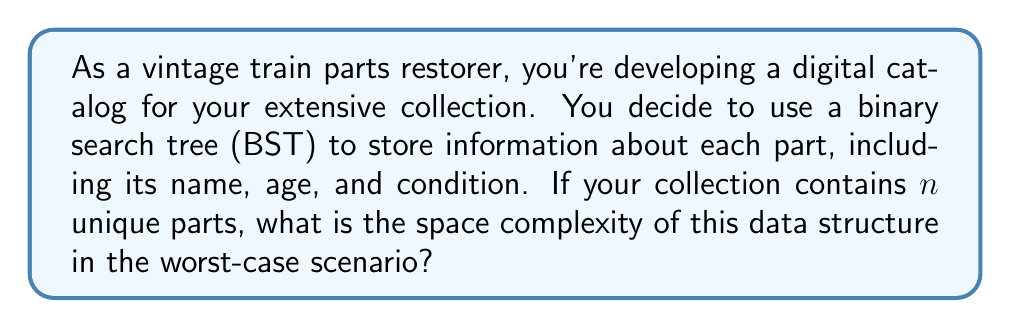Can you solve this math problem? To determine the space complexity of the binary search tree (BST) for cataloging vintage train parts, let's break down the problem:

1. Each node in the BST represents a train part and contains:
   - Name (string)
   - Age (integer)
   - Condition (string)
   - Two pointers (left and right child)

2. In the worst-case scenario, the BST becomes unbalanced and degenerates into a linked list. This occurs when parts are inserted in sorted order (e.g., by name or age).

3. Space complexity analysis:
   - Each node requires constant space, let's call it $c$.
   - In the worst case, we have $n$ nodes (one for each unique part).
   - Total space used: $S(n) = c \cdot n$

4. Applying Big O notation:
   - We drop the constant factor $c$.
   - The space complexity becomes $O(n)$.

5. Additional considerations:
   - The space complexity remains $O(n)$ even if we store additional metadata for each part.
   - If we implement balancing (e.g., using an AVL tree or Red-Black tree), the worst-case space complexity is still $O(n)$, but with better average-case time complexity for operations.

Therefore, the worst-case space complexity of the BST for cataloging $n$ vintage train parts is $O(n)$.
Answer: $O(n)$ 